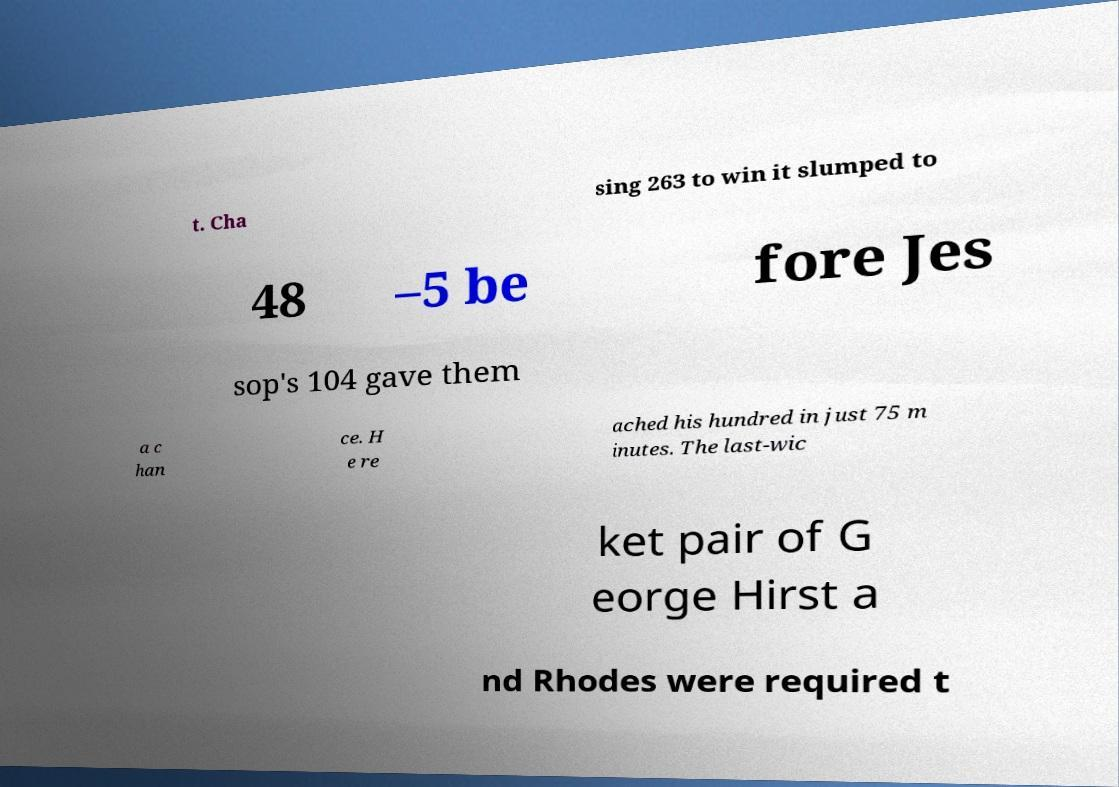What messages or text are displayed in this image? I need them in a readable, typed format. t. Cha sing 263 to win it slumped to 48 –5 be fore Jes sop's 104 gave them a c han ce. H e re ached his hundred in just 75 m inutes. The last-wic ket pair of G eorge Hirst a nd Rhodes were required t 